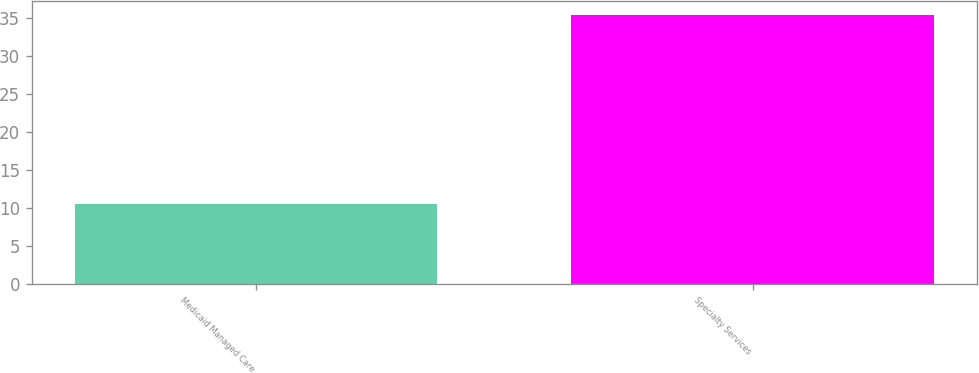Convert chart to OTSL. <chart><loc_0><loc_0><loc_500><loc_500><bar_chart><fcel>Medicaid Managed Care<fcel>Specialty Services<nl><fcel>10.5<fcel>35.4<nl></chart> 